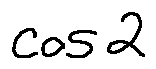Convert formula to latex. <formula><loc_0><loc_0><loc_500><loc_500>\cos 2</formula> 